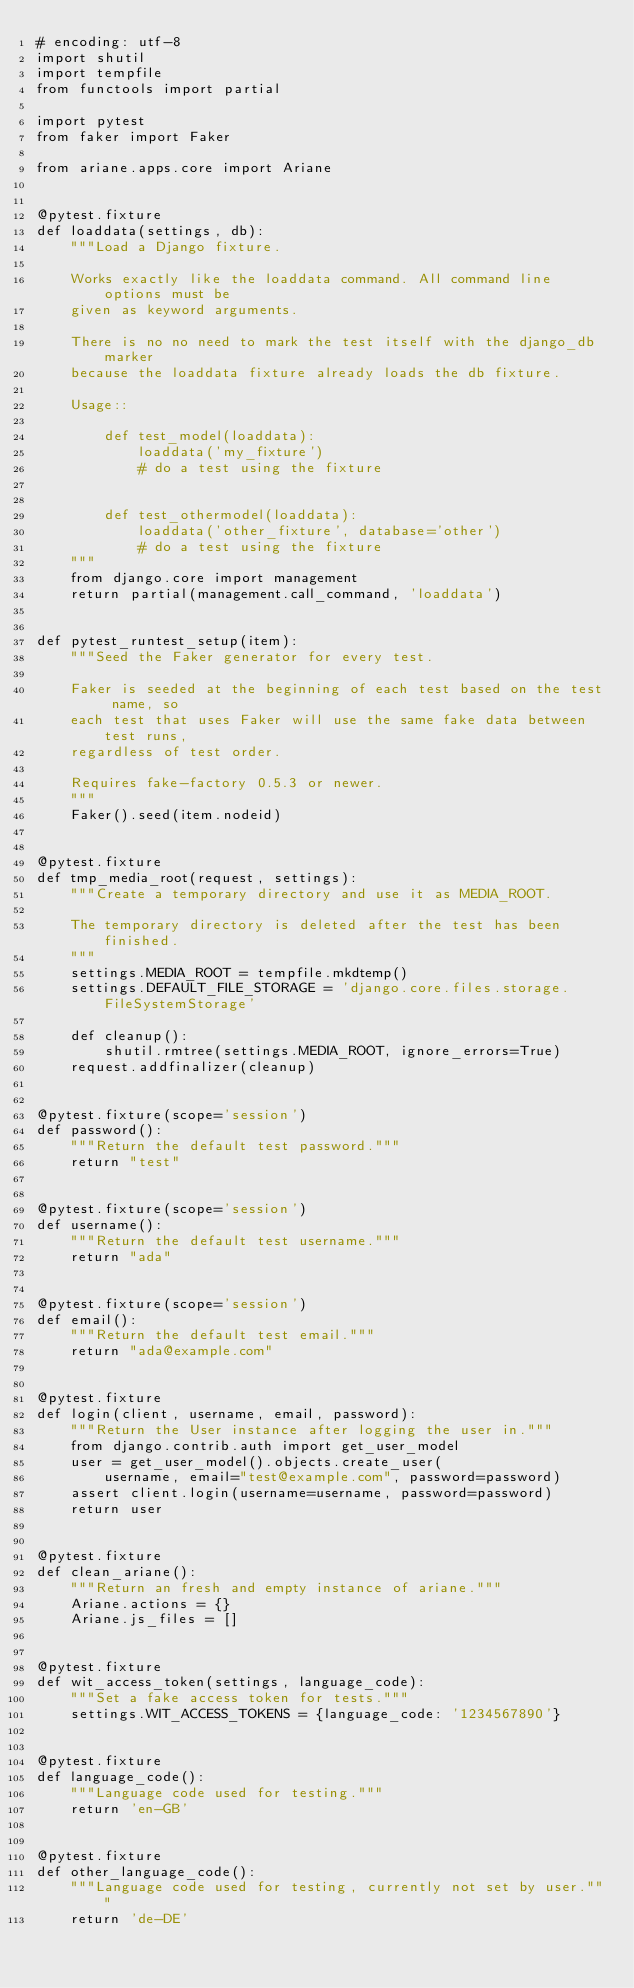Convert code to text. <code><loc_0><loc_0><loc_500><loc_500><_Python_># encoding: utf-8
import shutil
import tempfile
from functools import partial

import pytest
from faker import Faker

from ariane.apps.core import Ariane


@pytest.fixture
def loaddata(settings, db):
    """Load a Django fixture.

    Works exactly like the loaddata command. All command line options must be
    given as keyword arguments.

    There is no no need to mark the test itself with the django_db marker
    because the loaddata fixture already loads the db fixture.

    Usage::

        def test_model(loaddata):
            loaddata('my_fixture')
            # do a test using the fixture


        def test_othermodel(loaddata):
            loaddata('other_fixture', database='other')
            # do a test using the fixture
    """
    from django.core import management
    return partial(management.call_command, 'loaddata')


def pytest_runtest_setup(item):
    """Seed the Faker generator for every test.

    Faker is seeded at the beginning of each test based on the test name, so
    each test that uses Faker will use the same fake data between test runs,
    regardless of test order.

    Requires fake-factory 0.5.3 or newer.
    """
    Faker().seed(item.nodeid)


@pytest.fixture
def tmp_media_root(request, settings):
    """Create a temporary directory and use it as MEDIA_ROOT.

    The temporary directory is deleted after the test has been finished.
    """
    settings.MEDIA_ROOT = tempfile.mkdtemp()
    settings.DEFAULT_FILE_STORAGE = 'django.core.files.storage.FileSystemStorage'

    def cleanup():
        shutil.rmtree(settings.MEDIA_ROOT, ignore_errors=True)
    request.addfinalizer(cleanup)


@pytest.fixture(scope='session')
def password():
    """Return the default test password."""
    return "test"


@pytest.fixture(scope='session')
def username():
    """Return the default test username."""
    return "ada"


@pytest.fixture(scope='session')
def email():
    """Return the default test email."""
    return "ada@example.com"


@pytest.fixture
def login(client, username, email, password):
    """Return the User instance after logging the user in."""
    from django.contrib.auth import get_user_model
    user = get_user_model().objects.create_user(
        username, email="test@example.com", password=password)
    assert client.login(username=username, password=password)
    return user


@pytest.fixture
def clean_ariane():
    """Return an fresh and empty instance of ariane."""
    Ariane.actions = {}
    Ariane.js_files = []


@pytest.fixture
def wit_access_token(settings, language_code):
    """Set a fake access token for tests."""
    settings.WIT_ACCESS_TOKENS = {language_code: '1234567890'}


@pytest.fixture
def language_code():
    """Language code used for testing."""
    return 'en-GB'


@pytest.fixture
def other_language_code():
    """Language code used for testing, currently not set by user."""
    return 'de-DE'
</code> 